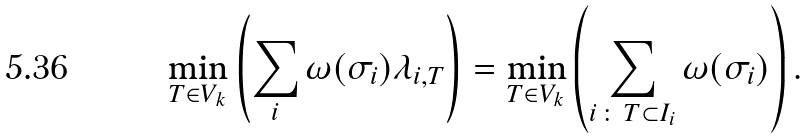Convert formula to latex. <formula><loc_0><loc_0><loc_500><loc_500>\min _ { T \in V _ { k } } \left ( \sum _ { i } \omega ( \sigma _ { i } ) \lambda _ { i , T } \right ) = \min _ { T \in V _ { k } } \left ( \sum _ { i \, \colon \, T \subset I _ { i } } \omega ( \sigma _ { i } ) \right ) .</formula> 